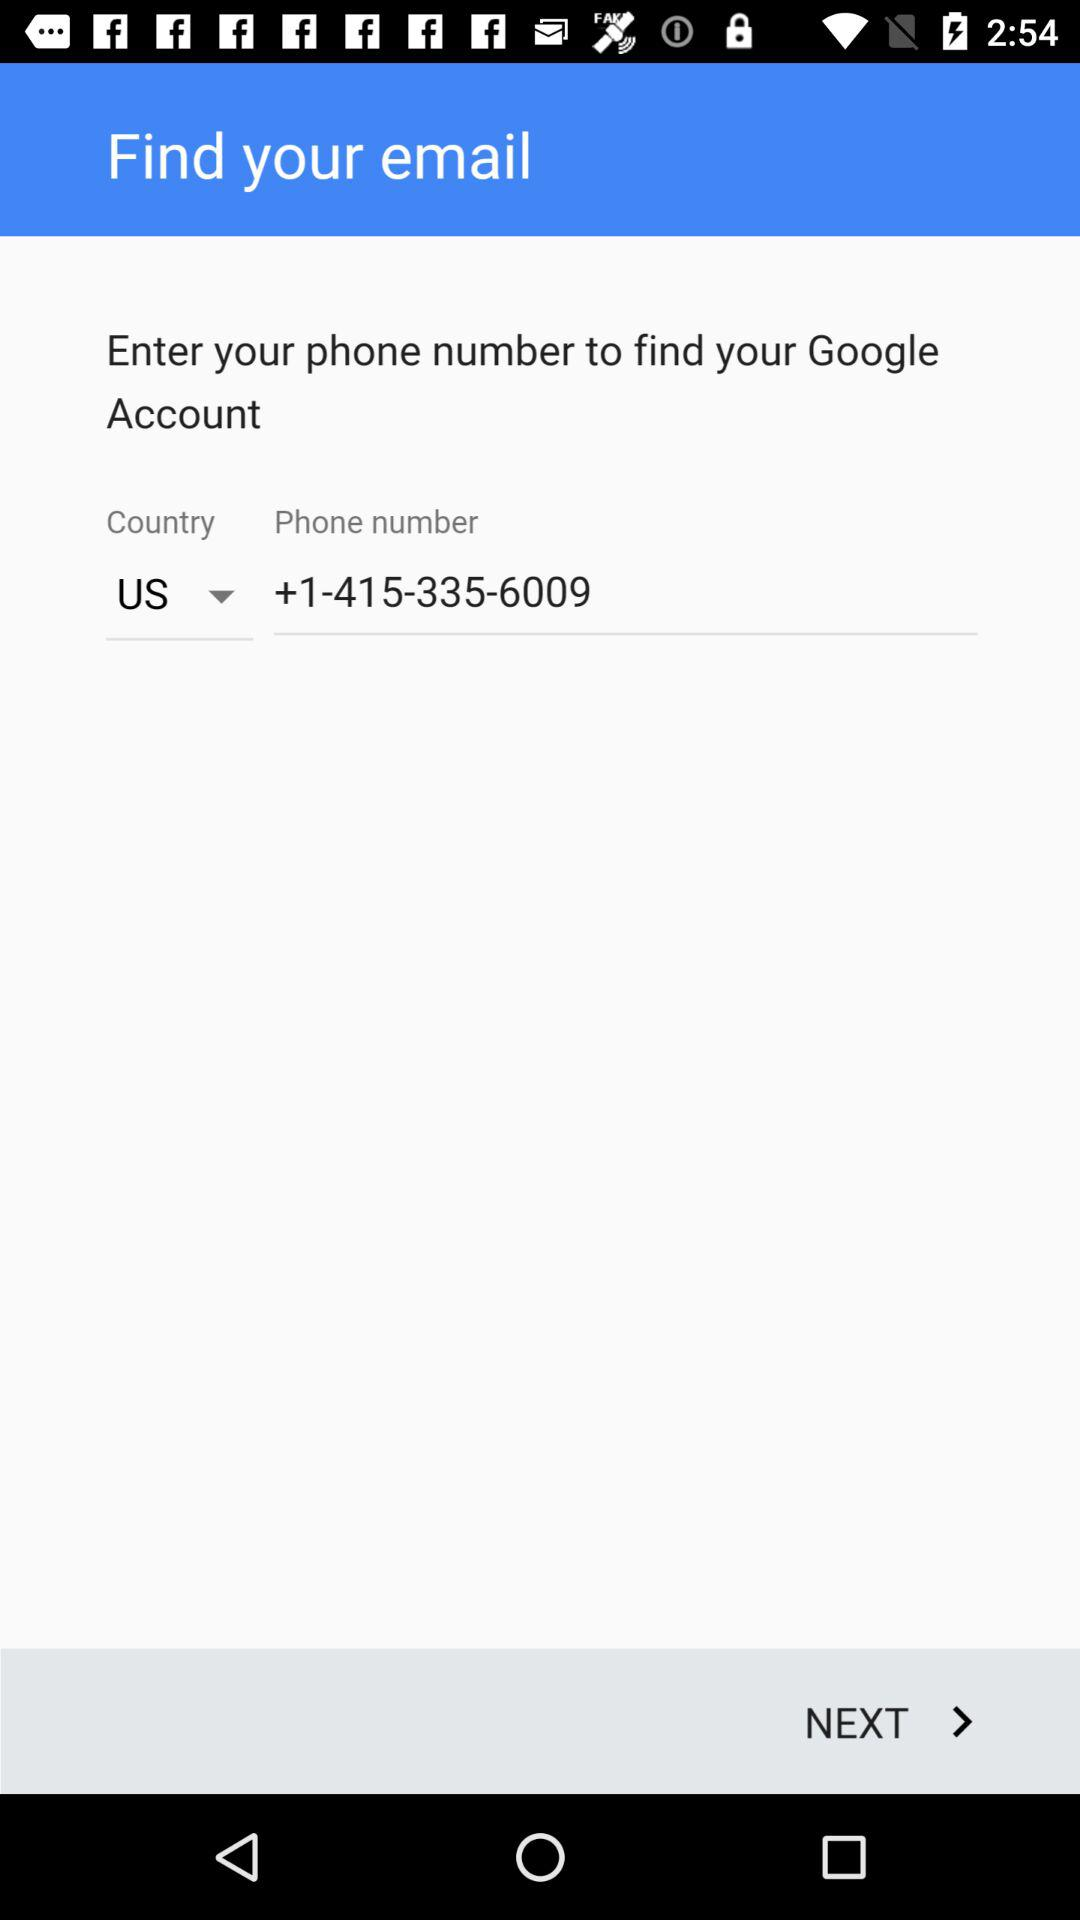How many digits are in the country code?
Answer the question using a single word or phrase. 1 